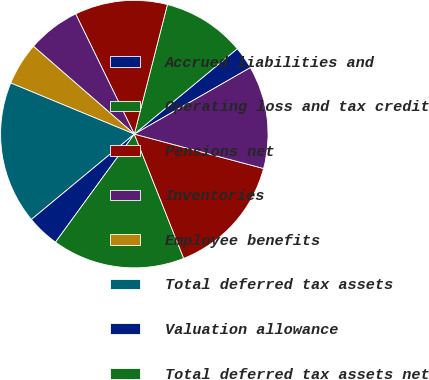<chart> <loc_0><loc_0><loc_500><loc_500><pie_chart><fcel>Accrued liabilities and<fcel>Operating loss and tax credit<fcel>Pensions net<fcel>Inventories<fcel>Employee benefits<fcel>Total deferred tax assets<fcel>Valuation allowance<fcel>Total deferred tax assets net<fcel>Goodwill<fcel>Depreciation and amortization<nl><fcel>2.74%<fcel>10.0%<fcel>11.21%<fcel>6.37%<fcel>5.16%<fcel>17.26%<fcel>3.95%<fcel>16.05%<fcel>14.84%<fcel>12.42%<nl></chart> 